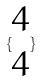<formula> <loc_0><loc_0><loc_500><loc_500>\{ \begin{matrix} 4 \\ 4 \end{matrix} \}</formula> 